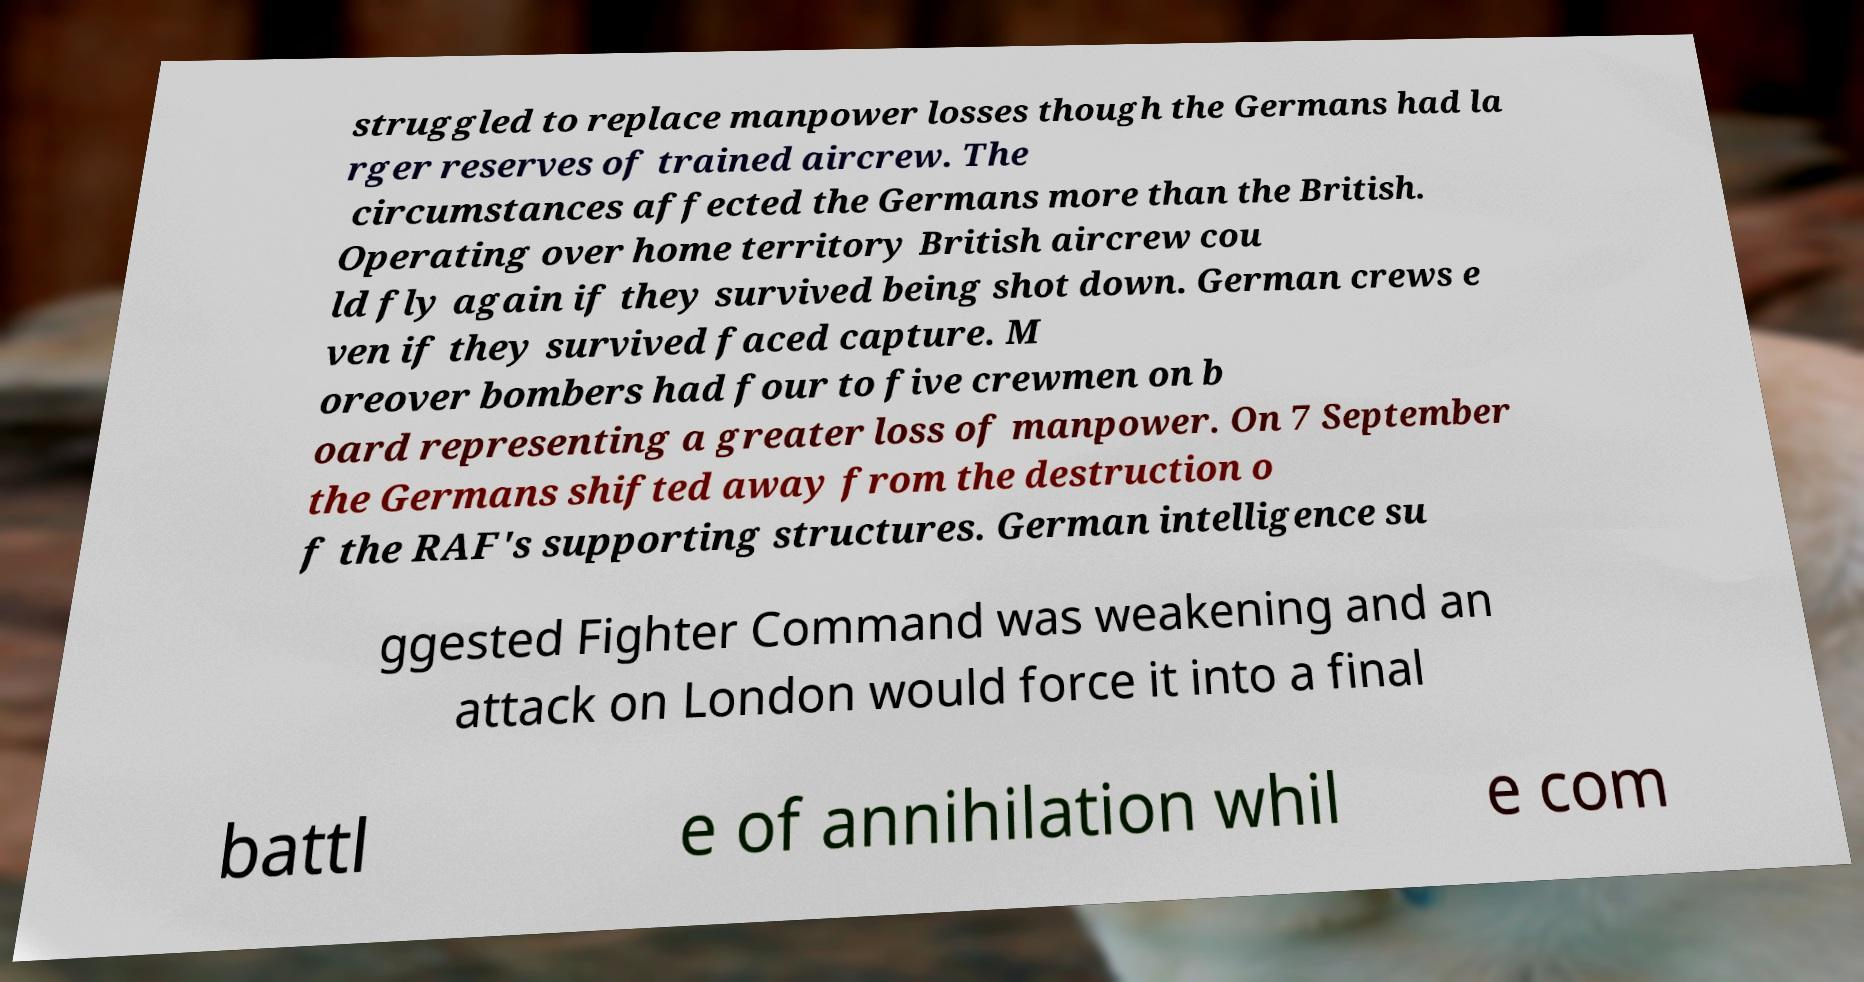Can you read and provide the text displayed in the image?This photo seems to have some interesting text. Can you extract and type it out for me? struggled to replace manpower losses though the Germans had la rger reserves of trained aircrew. The circumstances affected the Germans more than the British. Operating over home territory British aircrew cou ld fly again if they survived being shot down. German crews e ven if they survived faced capture. M oreover bombers had four to five crewmen on b oard representing a greater loss of manpower. On 7 September the Germans shifted away from the destruction o f the RAF's supporting structures. German intelligence su ggested Fighter Command was weakening and an attack on London would force it into a final battl e of annihilation whil e com 